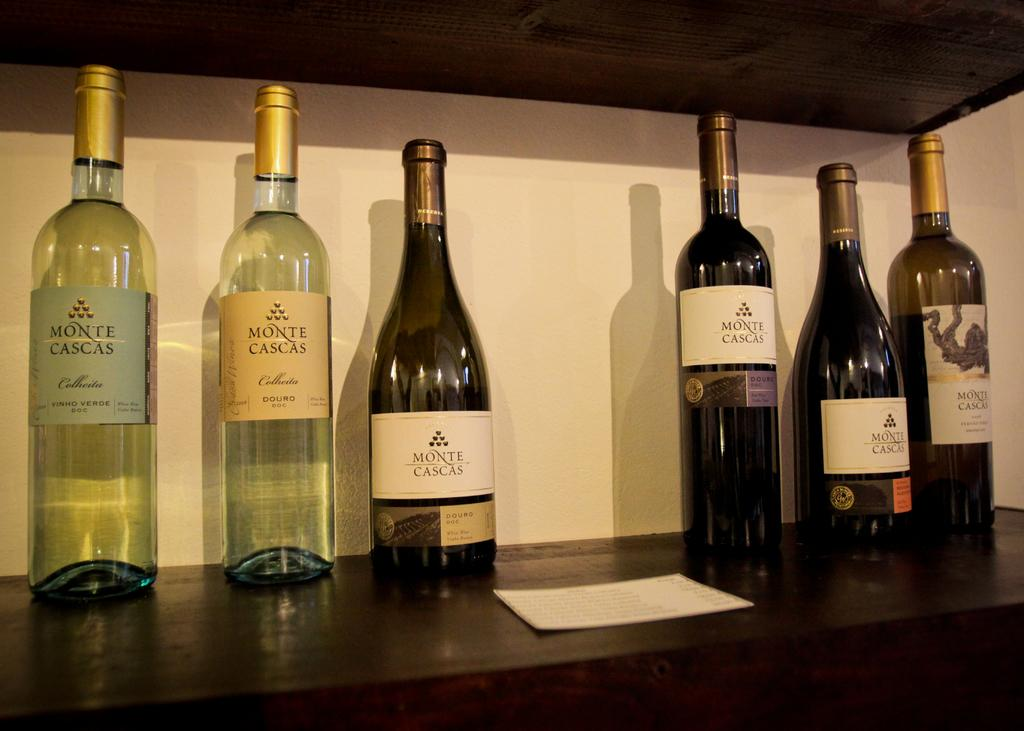What type of beverage containers are present in the image? There are wine bottles in the image. Where are the wine bottles located? The wine bottles are placed on a surface. What other item can be seen in the image? There is a card in the image. Where is the card located? The card is placed in a shelf. How many geese are present in the image? There are no geese present in the image. What type of amphibian can be seen interacting with the wine bottles in the image? There are no amphibians, such as frogs, present in the image. 